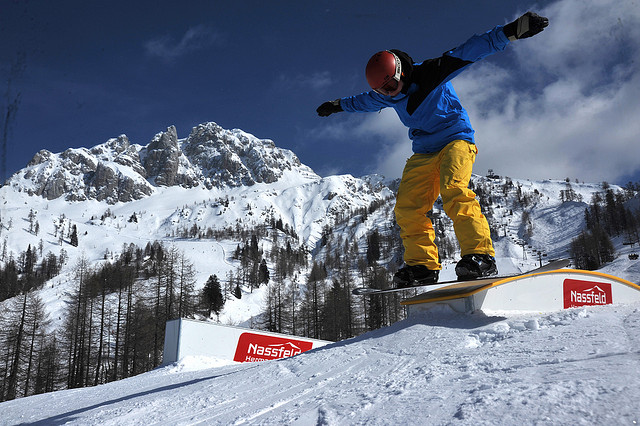Can you describe the snowboarder's attire? Certainly. The snowboarder is outfitted in a blue jacket paired with vibrant yellow pants, providing a contrast against the snowy background. They are also wearing a red helmet, ensuring head protection, and goggles which are essential for shielding their eyes from the bright sun and the cold wind. 